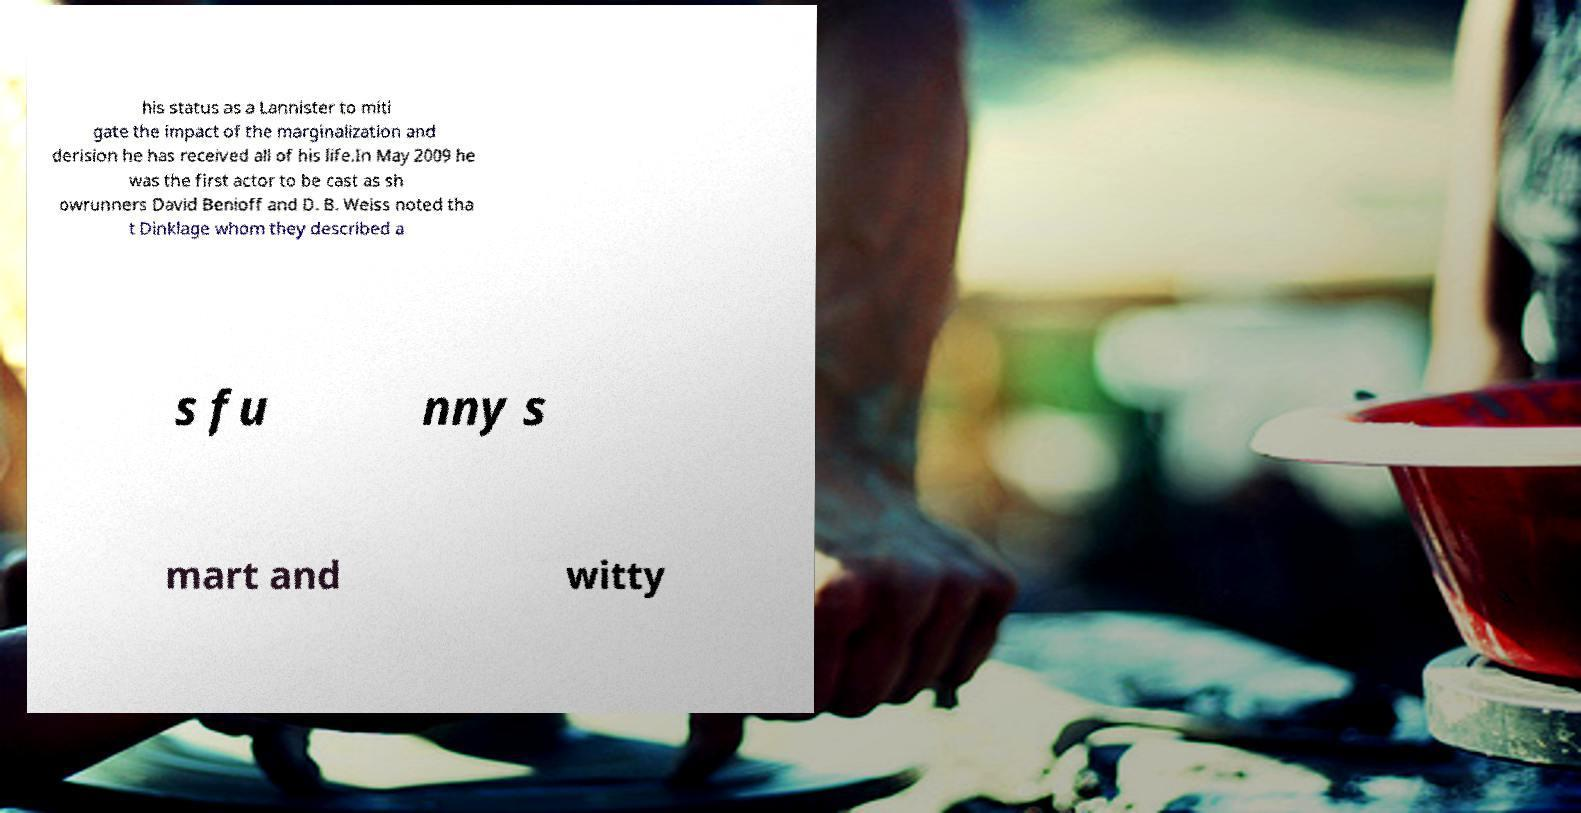What messages or text are displayed in this image? I need them in a readable, typed format. his status as a Lannister to miti gate the impact of the marginalization and derision he has received all of his life.In May 2009 he was the first actor to be cast as sh owrunners David Benioff and D. B. Weiss noted tha t Dinklage whom they described a s fu nny s mart and witty 